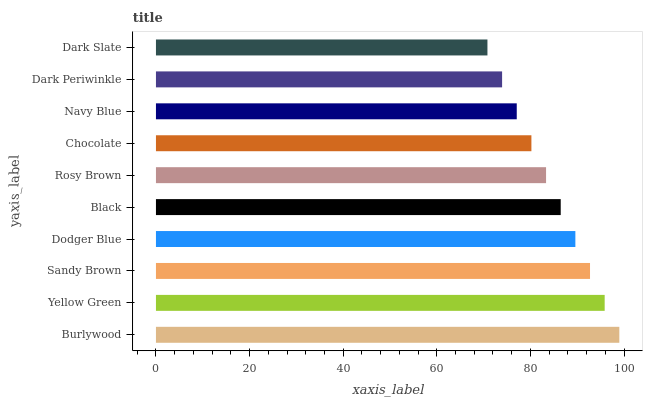Is Dark Slate the minimum?
Answer yes or no. Yes. Is Burlywood the maximum?
Answer yes or no. Yes. Is Yellow Green the minimum?
Answer yes or no. No. Is Yellow Green the maximum?
Answer yes or no. No. Is Burlywood greater than Yellow Green?
Answer yes or no. Yes. Is Yellow Green less than Burlywood?
Answer yes or no. Yes. Is Yellow Green greater than Burlywood?
Answer yes or no. No. Is Burlywood less than Yellow Green?
Answer yes or no. No. Is Black the high median?
Answer yes or no. Yes. Is Rosy Brown the low median?
Answer yes or no. Yes. Is Navy Blue the high median?
Answer yes or no. No. Is Chocolate the low median?
Answer yes or no. No. 